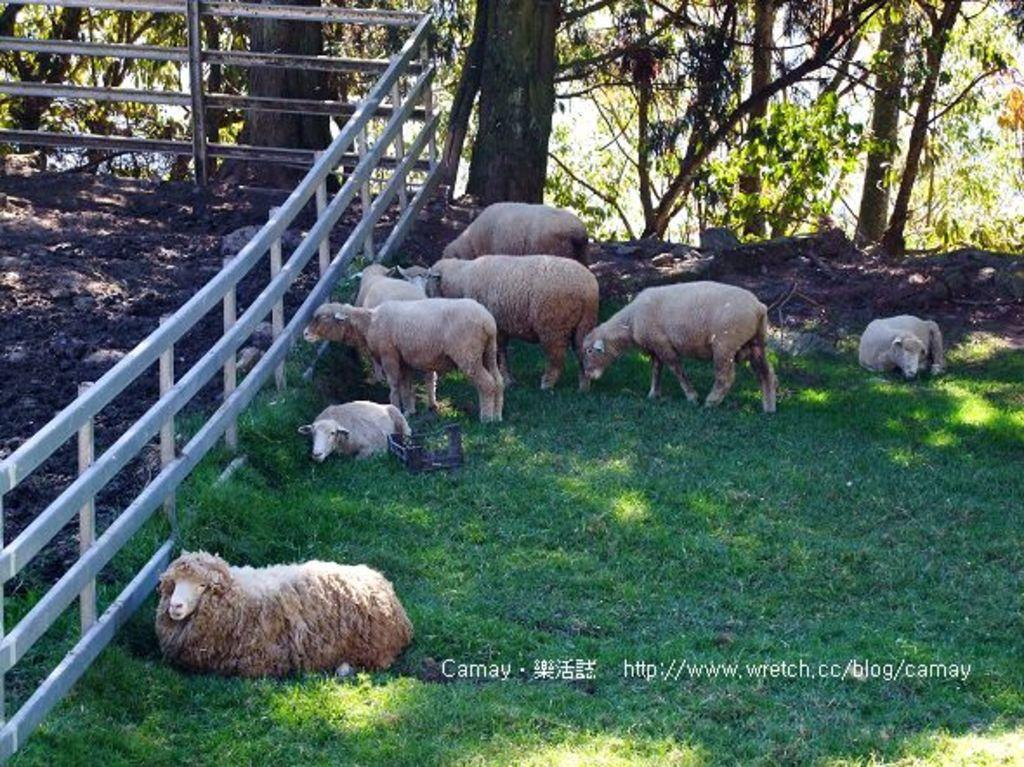What type of animals are in the image? There are sheep in the image. What color are the sheep? The sheep are white in color. What type of vegetation is present in the image? There is grass in the image. What other natural elements can be seen in the image? There are trees in the image. What idea does the tree in the image represent? There is no specific idea represented by the tree in the image; it is simply a natural element in the scene. 